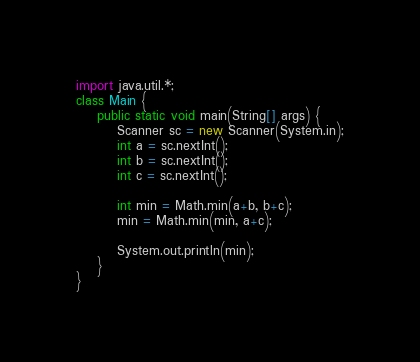<code> <loc_0><loc_0><loc_500><loc_500><_Java_>import java.util.*;
class Main {
    public static void main(String[] args) {
        Scanner sc = new Scanner(System.in);
        int a = sc.nextInt();
        int b = sc.nextInt();
        int c = sc.nextInt();

        int min = Math.min(a+b, b+c);
        min = Math.min(min, a+c);

        System.out.println(min);
    }
}</code> 